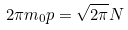<formula> <loc_0><loc_0><loc_500><loc_500>2 \pi m _ { 0 } p = \sqrt { 2 \pi } N</formula> 